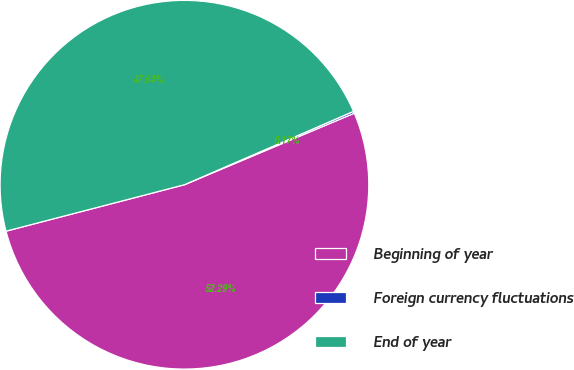<chart> <loc_0><loc_0><loc_500><loc_500><pie_chart><fcel>Beginning of year<fcel>Foreign currency fluctuations<fcel>End of year<nl><fcel>52.29%<fcel>0.17%<fcel>47.54%<nl></chart> 